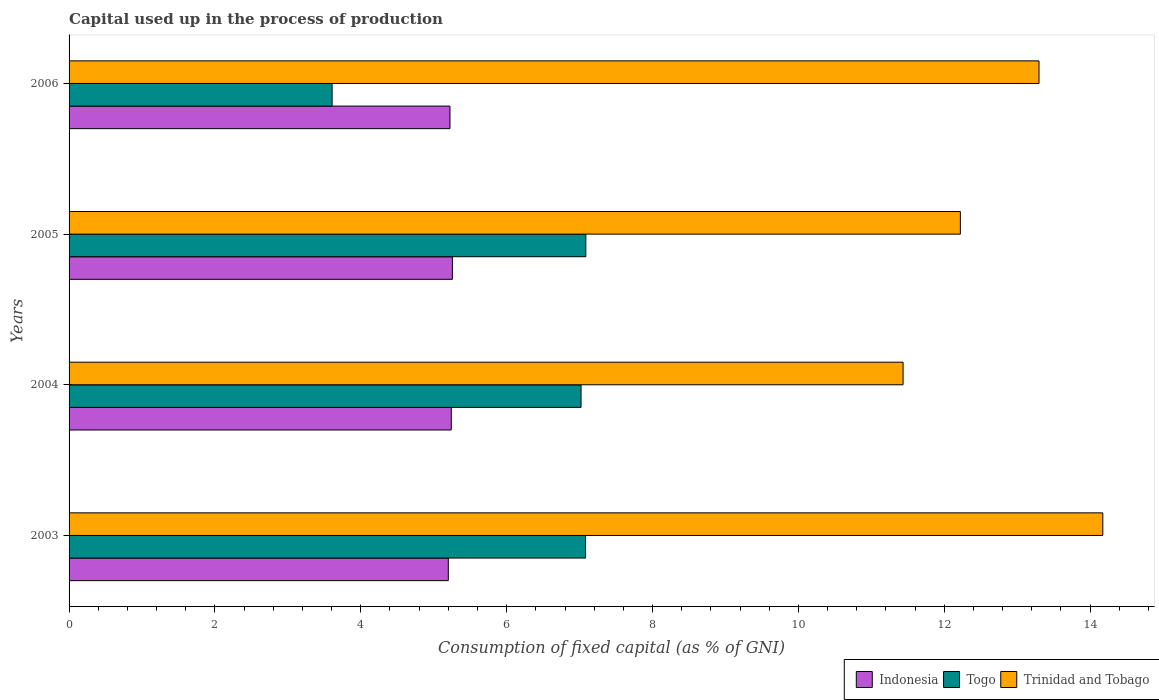How many groups of bars are there?
Offer a terse response. 4. Are the number of bars per tick equal to the number of legend labels?
Offer a terse response. Yes. How many bars are there on the 1st tick from the top?
Your answer should be compact. 3. How many bars are there on the 1st tick from the bottom?
Your answer should be compact. 3. What is the label of the 3rd group of bars from the top?
Your response must be concise. 2004. What is the capital used up in the process of production in Togo in 2006?
Make the answer very short. 3.61. Across all years, what is the maximum capital used up in the process of production in Indonesia?
Give a very brief answer. 5.26. Across all years, what is the minimum capital used up in the process of production in Indonesia?
Give a very brief answer. 5.2. In which year was the capital used up in the process of production in Togo maximum?
Provide a short and direct response. 2005. What is the total capital used up in the process of production in Togo in the graph?
Your answer should be very brief. 24.79. What is the difference between the capital used up in the process of production in Indonesia in 2003 and that in 2006?
Provide a succinct answer. -0.02. What is the difference between the capital used up in the process of production in Indonesia in 2004 and the capital used up in the process of production in Trinidad and Tobago in 2003?
Provide a succinct answer. -8.93. What is the average capital used up in the process of production in Indonesia per year?
Keep it short and to the point. 5.23. In the year 2005, what is the difference between the capital used up in the process of production in Trinidad and Tobago and capital used up in the process of production in Indonesia?
Keep it short and to the point. 6.97. In how many years, is the capital used up in the process of production in Togo greater than 6.4 %?
Make the answer very short. 3. What is the ratio of the capital used up in the process of production in Indonesia in 2003 to that in 2004?
Give a very brief answer. 0.99. Is the capital used up in the process of production in Togo in 2004 less than that in 2006?
Your answer should be very brief. No. What is the difference between the highest and the second highest capital used up in the process of production in Indonesia?
Your answer should be very brief. 0.02. What is the difference between the highest and the lowest capital used up in the process of production in Togo?
Ensure brevity in your answer.  3.48. What does the 1st bar from the top in 2003 represents?
Offer a terse response. Trinidad and Tobago. What does the 2nd bar from the bottom in 2005 represents?
Your response must be concise. Togo. Is it the case that in every year, the sum of the capital used up in the process of production in Trinidad and Tobago and capital used up in the process of production in Indonesia is greater than the capital used up in the process of production in Togo?
Your answer should be compact. Yes. What is the difference between two consecutive major ticks on the X-axis?
Offer a very short reply. 2. Does the graph contain any zero values?
Your answer should be compact. No. How many legend labels are there?
Make the answer very short. 3. What is the title of the graph?
Provide a succinct answer. Capital used up in the process of production. Does "Serbia" appear as one of the legend labels in the graph?
Keep it short and to the point. No. What is the label or title of the X-axis?
Your answer should be compact. Consumption of fixed capital (as % of GNI). What is the label or title of the Y-axis?
Keep it short and to the point. Years. What is the Consumption of fixed capital (as % of GNI) of Indonesia in 2003?
Your response must be concise. 5.2. What is the Consumption of fixed capital (as % of GNI) in Togo in 2003?
Your answer should be compact. 7.08. What is the Consumption of fixed capital (as % of GNI) of Trinidad and Tobago in 2003?
Your answer should be compact. 14.17. What is the Consumption of fixed capital (as % of GNI) of Indonesia in 2004?
Provide a short and direct response. 5.24. What is the Consumption of fixed capital (as % of GNI) of Togo in 2004?
Offer a terse response. 7.02. What is the Consumption of fixed capital (as % of GNI) of Trinidad and Tobago in 2004?
Make the answer very short. 11.44. What is the Consumption of fixed capital (as % of GNI) of Indonesia in 2005?
Keep it short and to the point. 5.26. What is the Consumption of fixed capital (as % of GNI) of Togo in 2005?
Offer a terse response. 7.09. What is the Consumption of fixed capital (as % of GNI) in Trinidad and Tobago in 2005?
Offer a terse response. 12.22. What is the Consumption of fixed capital (as % of GNI) of Indonesia in 2006?
Provide a succinct answer. 5.22. What is the Consumption of fixed capital (as % of GNI) of Togo in 2006?
Make the answer very short. 3.61. What is the Consumption of fixed capital (as % of GNI) of Trinidad and Tobago in 2006?
Offer a very short reply. 13.3. Across all years, what is the maximum Consumption of fixed capital (as % of GNI) of Indonesia?
Ensure brevity in your answer.  5.26. Across all years, what is the maximum Consumption of fixed capital (as % of GNI) in Togo?
Give a very brief answer. 7.09. Across all years, what is the maximum Consumption of fixed capital (as % of GNI) in Trinidad and Tobago?
Offer a terse response. 14.17. Across all years, what is the minimum Consumption of fixed capital (as % of GNI) in Indonesia?
Make the answer very short. 5.2. Across all years, what is the minimum Consumption of fixed capital (as % of GNI) in Togo?
Offer a very short reply. 3.61. Across all years, what is the minimum Consumption of fixed capital (as % of GNI) in Trinidad and Tobago?
Provide a succinct answer. 11.44. What is the total Consumption of fixed capital (as % of GNI) of Indonesia in the graph?
Offer a very short reply. 20.92. What is the total Consumption of fixed capital (as % of GNI) of Togo in the graph?
Your answer should be compact. 24.79. What is the total Consumption of fixed capital (as % of GNI) in Trinidad and Tobago in the graph?
Offer a very short reply. 51.13. What is the difference between the Consumption of fixed capital (as % of GNI) of Indonesia in 2003 and that in 2004?
Give a very brief answer. -0.04. What is the difference between the Consumption of fixed capital (as % of GNI) in Togo in 2003 and that in 2004?
Your answer should be very brief. 0.06. What is the difference between the Consumption of fixed capital (as % of GNI) in Trinidad and Tobago in 2003 and that in 2004?
Give a very brief answer. 2.74. What is the difference between the Consumption of fixed capital (as % of GNI) in Indonesia in 2003 and that in 2005?
Offer a terse response. -0.06. What is the difference between the Consumption of fixed capital (as % of GNI) in Togo in 2003 and that in 2005?
Keep it short and to the point. -0. What is the difference between the Consumption of fixed capital (as % of GNI) in Trinidad and Tobago in 2003 and that in 2005?
Ensure brevity in your answer.  1.95. What is the difference between the Consumption of fixed capital (as % of GNI) of Indonesia in 2003 and that in 2006?
Offer a terse response. -0.02. What is the difference between the Consumption of fixed capital (as % of GNI) of Togo in 2003 and that in 2006?
Provide a succinct answer. 3.48. What is the difference between the Consumption of fixed capital (as % of GNI) of Trinidad and Tobago in 2003 and that in 2006?
Ensure brevity in your answer.  0.87. What is the difference between the Consumption of fixed capital (as % of GNI) in Indonesia in 2004 and that in 2005?
Make the answer very short. -0.02. What is the difference between the Consumption of fixed capital (as % of GNI) in Togo in 2004 and that in 2005?
Keep it short and to the point. -0.07. What is the difference between the Consumption of fixed capital (as % of GNI) in Trinidad and Tobago in 2004 and that in 2005?
Provide a short and direct response. -0.79. What is the difference between the Consumption of fixed capital (as % of GNI) in Indonesia in 2004 and that in 2006?
Provide a succinct answer. 0.02. What is the difference between the Consumption of fixed capital (as % of GNI) in Togo in 2004 and that in 2006?
Make the answer very short. 3.41. What is the difference between the Consumption of fixed capital (as % of GNI) in Trinidad and Tobago in 2004 and that in 2006?
Offer a terse response. -1.86. What is the difference between the Consumption of fixed capital (as % of GNI) of Indonesia in 2005 and that in 2006?
Ensure brevity in your answer.  0.03. What is the difference between the Consumption of fixed capital (as % of GNI) in Togo in 2005 and that in 2006?
Ensure brevity in your answer.  3.48. What is the difference between the Consumption of fixed capital (as % of GNI) of Trinidad and Tobago in 2005 and that in 2006?
Offer a terse response. -1.08. What is the difference between the Consumption of fixed capital (as % of GNI) of Indonesia in 2003 and the Consumption of fixed capital (as % of GNI) of Togo in 2004?
Keep it short and to the point. -1.82. What is the difference between the Consumption of fixed capital (as % of GNI) of Indonesia in 2003 and the Consumption of fixed capital (as % of GNI) of Trinidad and Tobago in 2004?
Provide a short and direct response. -6.24. What is the difference between the Consumption of fixed capital (as % of GNI) in Togo in 2003 and the Consumption of fixed capital (as % of GNI) in Trinidad and Tobago in 2004?
Offer a terse response. -4.35. What is the difference between the Consumption of fixed capital (as % of GNI) in Indonesia in 2003 and the Consumption of fixed capital (as % of GNI) in Togo in 2005?
Your response must be concise. -1.89. What is the difference between the Consumption of fixed capital (as % of GNI) in Indonesia in 2003 and the Consumption of fixed capital (as % of GNI) in Trinidad and Tobago in 2005?
Your answer should be very brief. -7.02. What is the difference between the Consumption of fixed capital (as % of GNI) in Togo in 2003 and the Consumption of fixed capital (as % of GNI) in Trinidad and Tobago in 2005?
Keep it short and to the point. -5.14. What is the difference between the Consumption of fixed capital (as % of GNI) of Indonesia in 2003 and the Consumption of fixed capital (as % of GNI) of Togo in 2006?
Make the answer very short. 1.59. What is the difference between the Consumption of fixed capital (as % of GNI) in Indonesia in 2003 and the Consumption of fixed capital (as % of GNI) in Trinidad and Tobago in 2006?
Make the answer very short. -8.1. What is the difference between the Consumption of fixed capital (as % of GNI) in Togo in 2003 and the Consumption of fixed capital (as % of GNI) in Trinidad and Tobago in 2006?
Your answer should be compact. -6.22. What is the difference between the Consumption of fixed capital (as % of GNI) of Indonesia in 2004 and the Consumption of fixed capital (as % of GNI) of Togo in 2005?
Your answer should be very brief. -1.85. What is the difference between the Consumption of fixed capital (as % of GNI) in Indonesia in 2004 and the Consumption of fixed capital (as % of GNI) in Trinidad and Tobago in 2005?
Your answer should be compact. -6.98. What is the difference between the Consumption of fixed capital (as % of GNI) of Togo in 2004 and the Consumption of fixed capital (as % of GNI) of Trinidad and Tobago in 2005?
Ensure brevity in your answer.  -5.2. What is the difference between the Consumption of fixed capital (as % of GNI) of Indonesia in 2004 and the Consumption of fixed capital (as % of GNI) of Togo in 2006?
Ensure brevity in your answer.  1.63. What is the difference between the Consumption of fixed capital (as % of GNI) in Indonesia in 2004 and the Consumption of fixed capital (as % of GNI) in Trinidad and Tobago in 2006?
Provide a short and direct response. -8.06. What is the difference between the Consumption of fixed capital (as % of GNI) in Togo in 2004 and the Consumption of fixed capital (as % of GNI) in Trinidad and Tobago in 2006?
Keep it short and to the point. -6.28. What is the difference between the Consumption of fixed capital (as % of GNI) in Indonesia in 2005 and the Consumption of fixed capital (as % of GNI) in Togo in 2006?
Your answer should be very brief. 1.65. What is the difference between the Consumption of fixed capital (as % of GNI) of Indonesia in 2005 and the Consumption of fixed capital (as % of GNI) of Trinidad and Tobago in 2006?
Keep it short and to the point. -8.04. What is the difference between the Consumption of fixed capital (as % of GNI) in Togo in 2005 and the Consumption of fixed capital (as % of GNI) in Trinidad and Tobago in 2006?
Ensure brevity in your answer.  -6.21. What is the average Consumption of fixed capital (as % of GNI) in Indonesia per year?
Give a very brief answer. 5.23. What is the average Consumption of fixed capital (as % of GNI) of Togo per year?
Your response must be concise. 6.2. What is the average Consumption of fixed capital (as % of GNI) of Trinidad and Tobago per year?
Keep it short and to the point. 12.78. In the year 2003, what is the difference between the Consumption of fixed capital (as % of GNI) in Indonesia and Consumption of fixed capital (as % of GNI) in Togo?
Your answer should be very brief. -1.88. In the year 2003, what is the difference between the Consumption of fixed capital (as % of GNI) of Indonesia and Consumption of fixed capital (as % of GNI) of Trinidad and Tobago?
Give a very brief answer. -8.97. In the year 2003, what is the difference between the Consumption of fixed capital (as % of GNI) of Togo and Consumption of fixed capital (as % of GNI) of Trinidad and Tobago?
Your answer should be very brief. -7.09. In the year 2004, what is the difference between the Consumption of fixed capital (as % of GNI) in Indonesia and Consumption of fixed capital (as % of GNI) in Togo?
Offer a very short reply. -1.78. In the year 2004, what is the difference between the Consumption of fixed capital (as % of GNI) in Indonesia and Consumption of fixed capital (as % of GNI) in Trinidad and Tobago?
Ensure brevity in your answer.  -6.19. In the year 2004, what is the difference between the Consumption of fixed capital (as % of GNI) in Togo and Consumption of fixed capital (as % of GNI) in Trinidad and Tobago?
Offer a very short reply. -4.42. In the year 2005, what is the difference between the Consumption of fixed capital (as % of GNI) of Indonesia and Consumption of fixed capital (as % of GNI) of Togo?
Provide a succinct answer. -1.83. In the year 2005, what is the difference between the Consumption of fixed capital (as % of GNI) in Indonesia and Consumption of fixed capital (as % of GNI) in Trinidad and Tobago?
Your answer should be very brief. -6.97. In the year 2005, what is the difference between the Consumption of fixed capital (as % of GNI) of Togo and Consumption of fixed capital (as % of GNI) of Trinidad and Tobago?
Your answer should be compact. -5.14. In the year 2006, what is the difference between the Consumption of fixed capital (as % of GNI) of Indonesia and Consumption of fixed capital (as % of GNI) of Togo?
Your response must be concise. 1.62. In the year 2006, what is the difference between the Consumption of fixed capital (as % of GNI) in Indonesia and Consumption of fixed capital (as % of GNI) in Trinidad and Tobago?
Your response must be concise. -8.08. In the year 2006, what is the difference between the Consumption of fixed capital (as % of GNI) in Togo and Consumption of fixed capital (as % of GNI) in Trinidad and Tobago?
Your answer should be very brief. -9.69. What is the ratio of the Consumption of fixed capital (as % of GNI) of Indonesia in 2003 to that in 2004?
Provide a short and direct response. 0.99. What is the ratio of the Consumption of fixed capital (as % of GNI) of Togo in 2003 to that in 2004?
Offer a terse response. 1.01. What is the ratio of the Consumption of fixed capital (as % of GNI) in Trinidad and Tobago in 2003 to that in 2004?
Provide a short and direct response. 1.24. What is the ratio of the Consumption of fixed capital (as % of GNI) in Togo in 2003 to that in 2005?
Keep it short and to the point. 1. What is the ratio of the Consumption of fixed capital (as % of GNI) of Trinidad and Tobago in 2003 to that in 2005?
Provide a short and direct response. 1.16. What is the ratio of the Consumption of fixed capital (as % of GNI) in Indonesia in 2003 to that in 2006?
Make the answer very short. 1. What is the ratio of the Consumption of fixed capital (as % of GNI) of Togo in 2003 to that in 2006?
Ensure brevity in your answer.  1.96. What is the ratio of the Consumption of fixed capital (as % of GNI) of Trinidad and Tobago in 2003 to that in 2006?
Offer a very short reply. 1.07. What is the ratio of the Consumption of fixed capital (as % of GNI) in Togo in 2004 to that in 2005?
Offer a very short reply. 0.99. What is the ratio of the Consumption of fixed capital (as % of GNI) in Trinidad and Tobago in 2004 to that in 2005?
Offer a very short reply. 0.94. What is the ratio of the Consumption of fixed capital (as % of GNI) of Togo in 2004 to that in 2006?
Your answer should be compact. 1.95. What is the ratio of the Consumption of fixed capital (as % of GNI) of Trinidad and Tobago in 2004 to that in 2006?
Offer a terse response. 0.86. What is the ratio of the Consumption of fixed capital (as % of GNI) of Indonesia in 2005 to that in 2006?
Offer a very short reply. 1.01. What is the ratio of the Consumption of fixed capital (as % of GNI) in Togo in 2005 to that in 2006?
Make the answer very short. 1.96. What is the ratio of the Consumption of fixed capital (as % of GNI) of Trinidad and Tobago in 2005 to that in 2006?
Keep it short and to the point. 0.92. What is the difference between the highest and the second highest Consumption of fixed capital (as % of GNI) in Indonesia?
Offer a very short reply. 0.02. What is the difference between the highest and the second highest Consumption of fixed capital (as % of GNI) of Togo?
Keep it short and to the point. 0. What is the difference between the highest and the second highest Consumption of fixed capital (as % of GNI) in Trinidad and Tobago?
Your answer should be very brief. 0.87. What is the difference between the highest and the lowest Consumption of fixed capital (as % of GNI) in Indonesia?
Your answer should be very brief. 0.06. What is the difference between the highest and the lowest Consumption of fixed capital (as % of GNI) of Togo?
Make the answer very short. 3.48. What is the difference between the highest and the lowest Consumption of fixed capital (as % of GNI) in Trinidad and Tobago?
Your answer should be very brief. 2.74. 